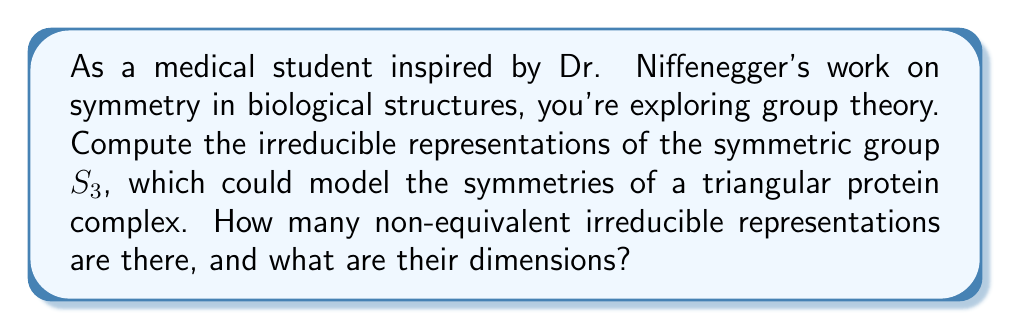Can you solve this math problem? Let's approach this step-by-step:

1) First, recall that the number of irreducible representations of a finite group is equal to the number of conjugacy classes of the group.

2) For $S_3$, we have 3 conjugacy classes:
   - $\{e\}$ (identity)
   - $\{(12), (23), (13)\}$ (transpositions)
   - $\{(123), (132)\}$ (3-cycles)

3) Therefore, $S_3$ has 3 irreducible representations.

4) The dimensions of these representations must satisfy:
   $$ \sum_{i} d_i^2 = |S_3| = 6 $$
   where $d_i$ are the dimensions of the irreducible representations.

5) We know that every group has a 1-dimensional trivial representation. So we have $d_1 = 1$.

6) The sign representation, which assigns +1 to even permutations and -1 to odd permutations, is also 1-dimensional. So $d_2 = 1$.

7) Given steps 4-6, we can deduce that the third representation must be 2-dimensional:
   $$ 1^2 + 1^2 + d_3^2 = 6 $$
   $$ d_3^2 = 4 $$
   $$ d_3 = 2 $$

8) Therefore, the three irreducible representations of $S_3$ are:
   - The trivial representation (1-dimensional)
   - The sign representation (1-dimensional)
   - A 2-dimensional representation
Answer: 3 irreducible representations: two 1-dimensional and one 2-dimensional. 